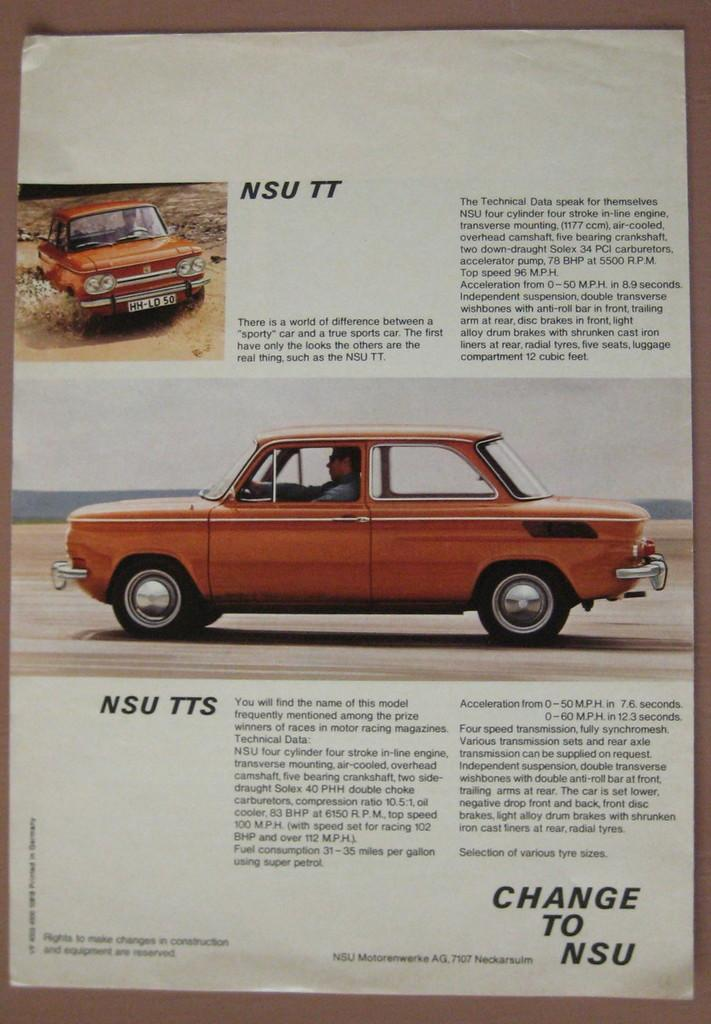What is on the wall in the image? There is a poster on the wall in the image. What is depicted on the poster? The poster features a man sitting inside a car. What is the position of the car in the poster? The car is on the ground in the poster. Are there any words or letters on the poster? Yes, there is text on the poster. Can you see any horses in the harbor in the image? There is no harbor or horse present in the image. What type of cough is the man in the car experiencing in the image? There is no indication of a cough or any medical condition in the image. 